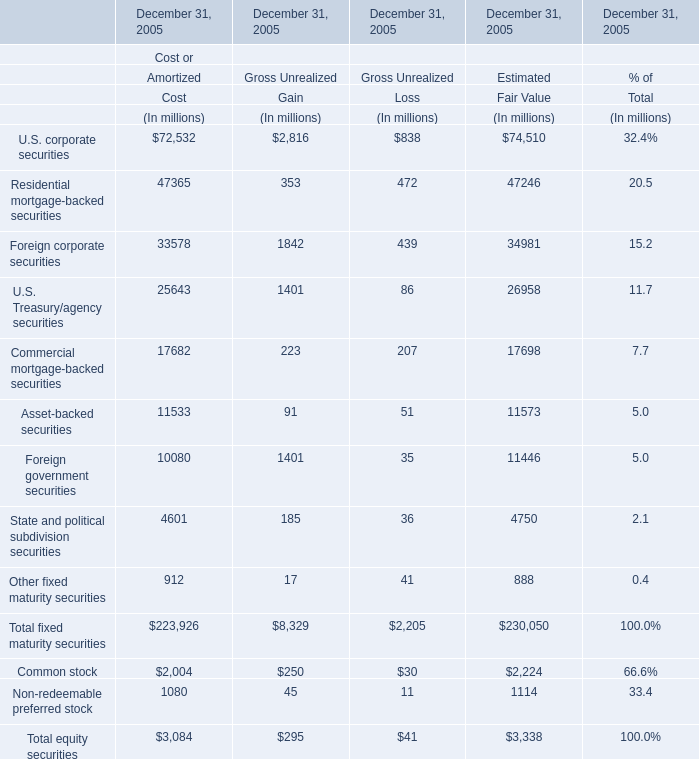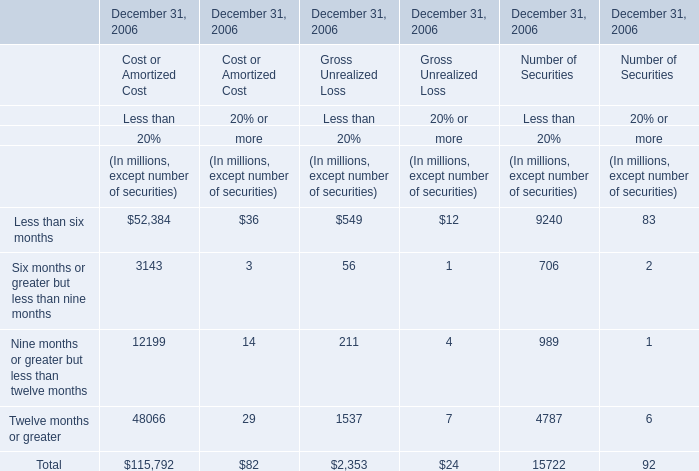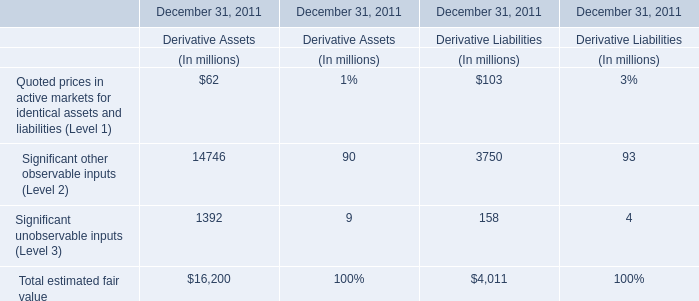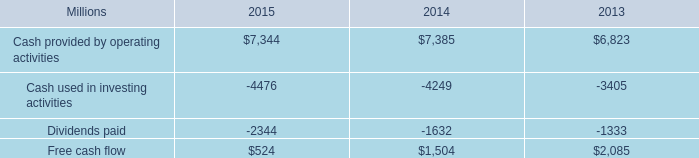what was the percentage change in free cash flow from 2014 to 2015? 
Computations: ((524 - 1504) / 1504)
Answer: -0.6516. 